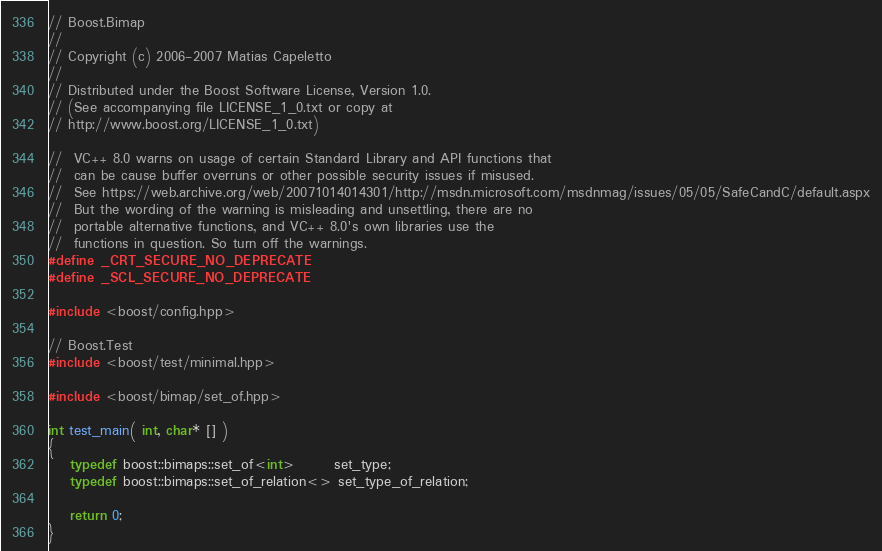<code> <loc_0><loc_0><loc_500><loc_500><_C++_>// Boost.Bimap
//
// Copyright (c) 2006-2007 Matias Capeletto
//
// Distributed under the Boost Software License, Version 1.0.
// (See accompanying file LICENSE_1_0.txt or copy at
// http://www.boost.org/LICENSE_1_0.txt)

//  VC++ 8.0 warns on usage of certain Standard Library and API functions that
//  can be cause buffer overruns or other possible security issues if misused.
//  See https://web.archive.org/web/20071014014301/http://msdn.microsoft.com/msdnmag/issues/05/05/SafeCandC/default.aspx
//  But the wording of the warning is misleading and unsettling, there are no
//  portable alternative functions, and VC++ 8.0's own libraries use the
//  functions in question. So turn off the warnings.
#define _CRT_SECURE_NO_DEPRECATE
#define _SCL_SECURE_NO_DEPRECATE

#include <boost/config.hpp>

// Boost.Test
#include <boost/test/minimal.hpp>

#include <boost/bimap/set_of.hpp>

int test_main( int, char* [] )
{
    typedef boost::bimaps::set_of<int>       set_type;
    typedef boost::bimaps::set_of_relation<> set_type_of_relation;

    return 0;
}

</code> 